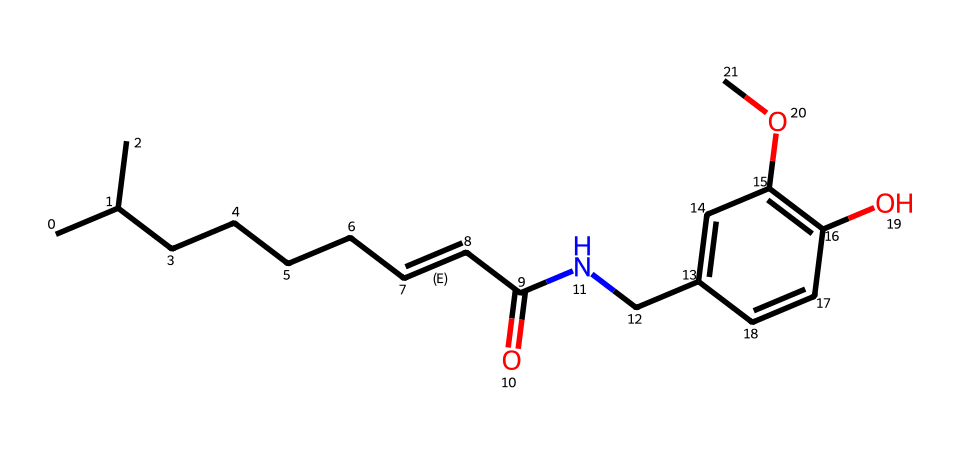how many rings are present in capsaicin's structure? In the provided SMILES, the notation contains one aromatic ring, indicated by the 'C1=CC' portion, suggesting a cyclic structure. Thus, there is one ring in the chemical structure.
Answer: one what is the functional group present in capsaicin? Observing the structure, we can identify the hydroxyl group (-OH) attached to the aromatic ring, indicating that capsaicin has a phenolic functional group.
Answer: phenolic how many carbon atoms are in capsaicin? By breaking down the SMILES representation, we can count the number of carbon atoms (C) represented. In total, there are 18 carbon atoms present in the entire structure.
Answer: eighteen what type of bond connects elements in capsaicin? In this structure, both single (sigma) bonds and double (pi) bonds are present, especially highlighted by the '/C=C/' part, which specifies a double bond between the carbon atoms in conjugation.
Answer: double and single does capsaicin contain any nitrogen atoms? The SMILES representation contains an 'N' character, which indicates the presence of one nitrogen atom within the molecule.
Answer: one is capsaicin classified as a phenol? Analyzing the presence of the hydroxyl group (-OH) attached to an aromatic ring, it qualifies as a phenol, which aligns with the definitions of chemical classifications.
Answer: yes what is the significance of the double bond in capsaicin's structure? The '/C=C/' notation indicates a double bond between two carbon atoms, which contributes to the molecule's reactivity and can influence the sensory properties, like spiciness and flavor profile.
Answer: reactivity and flavor 